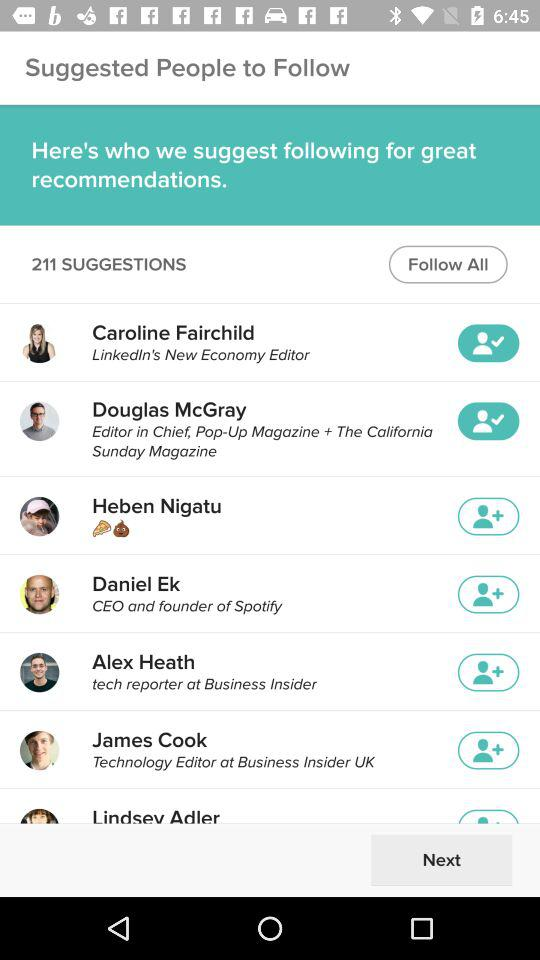How many people are suggested to be followed?
Answer the question using a single word or phrase. 211 